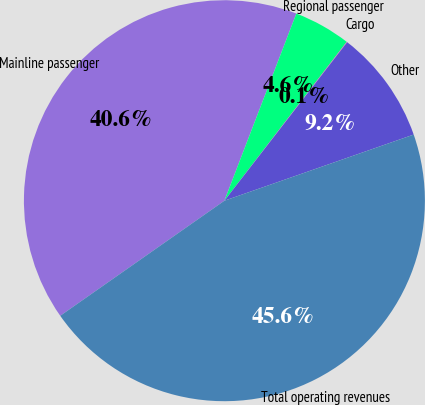<chart> <loc_0><loc_0><loc_500><loc_500><pie_chart><fcel>Mainline passenger<fcel>Regional passenger<fcel>Cargo<fcel>Other<fcel>Total operating revenues<nl><fcel>40.57%<fcel>4.6%<fcel>0.05%<fcel>9.16%<fcel>45.62%<nl></chart> 